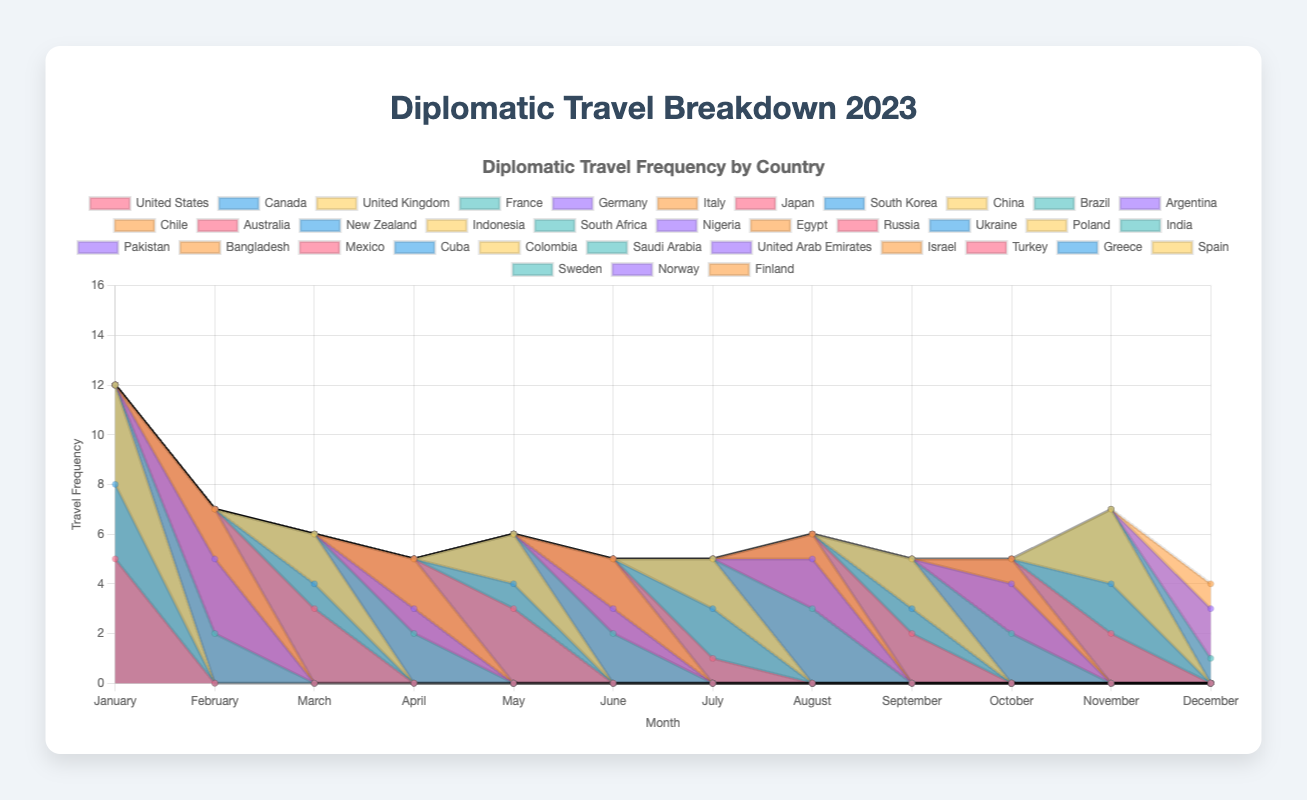What is the overall trend in diplomatic travel frequency throughout 2023? By looking at the filled areas for each country, observe if the combined height of all stacked areas increases, decreases, or remains roughly constant over the months.
Answer: The overall frequency remains relatively constant Which month has the most robust travel frequency, and what is the combined highest frequency for that month? Identify the month where the stacked areas are tallest. Sum the frequencies for each country for that month to find the combined highest frequency.
Answer: January, 12 travels Which country stands out with the highest travel frequency in January? For January, compare the heights of the colored areas representing each country. The tallest area indicates the highest frequency for that month.
Answer: United States How does the frequency of travel to European countries change from February to December? Track and compare the heights of the areas for European countries (France, Germany, Italy, Russia, Ukraine, Poland, Turkey, Greece, Spain, Sweden, Norway, Finland) across the months. Observe their growth or reduction in stacked area heights.
Answer: Generally decreases Is there any country that has consistent travel frequency month over month? Look for a country that has similar height areas across multiple months, indicating a consistent travel frequency.
Answer: No consistent pattern Compare travel frequencies to Asian countries in March and August. Which month had more travels? Sum up the travel frequencies for Japan, South Korea, China in March and India, Pakistan, Bangladesh in August and compare the sums.
Answer: March had 6, August had 6 Which month had the least travel frequency to South America? Identify the months with travels to Brazil, Argentina, Chile (South America) and compare their combined travel frequencies.
Answer: July What can be inferred about the travel frequency to African countries in June compared to other months? Check the heights of the areas for South Africa, Nigeria, and Egypt in June and compare them to other months.
Answer: Higher in June How does the travel frequency to Middle Eastern countries in October compare with November? Compare the areas representing Saudi Arabia, UAE, and Israel in October with Turkey, Greece, and Spain in November. Observe the heights.
Answer: November is higher Which countries saw the largest increase in travel frequency from the beginning (January) to the end of the year (December)? Compare the travel frequencies for individual countries in January and December, identifying those with the largest difference.
Answer: Sweden, Norway 